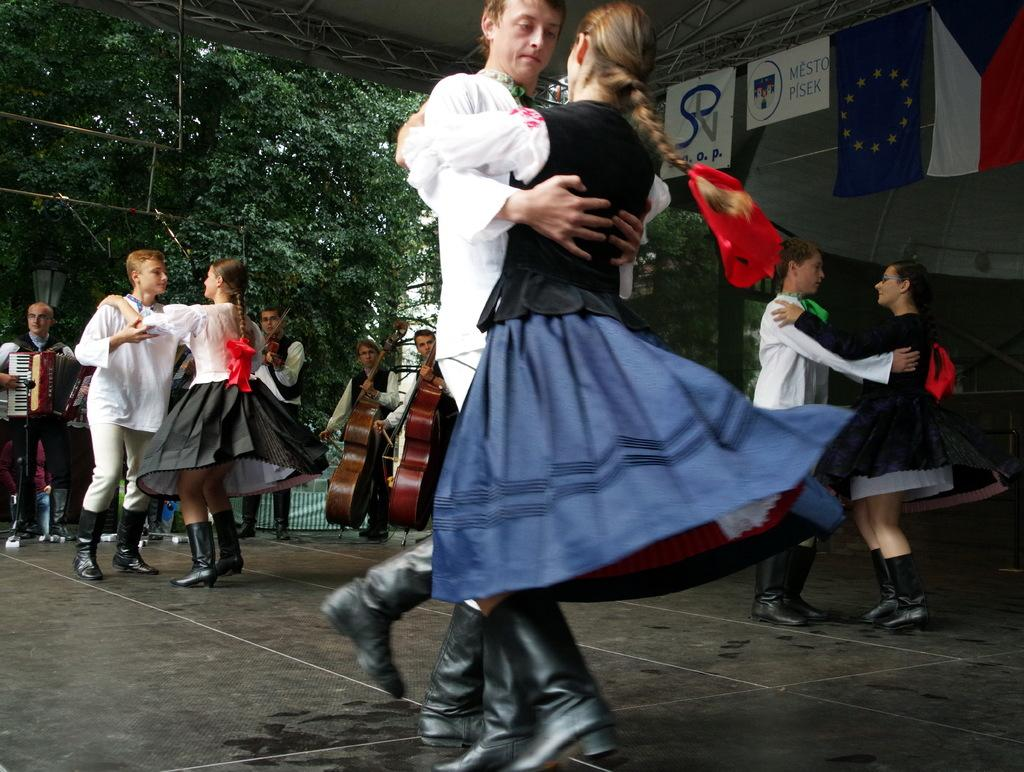What are the persons in the foreground of the image doing? There is a group of persons performing on the floor. What can be seen in the background of the image? In the background, there are persons holding guitars, flags, trees, fencing, and the sky. Can you describe the musical instruments being used in the image? The persons holding guitars in the background are using guitars as musical instruments. What type of natural elements are visible in the background? Trees and the sky are visible in the background. How many rabbits can be seen working on the fencing in the image? There are no rabbits present in the image, and they are not working on the fencing. What is the primary method used to increase the number of flags in the image? There is no indication in the image that the number of flags is being increased, and no method is shown for doing so. 